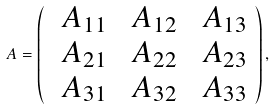<formula> <loc_0><loc_0><loc_500><loc_500>\ A = \left ( \begin{array} { c c c } \ A _ { 1 1 } & \ A _ { 1 2 } & \ A _ { 1 3 } \\ \ A _ { 2 1 } & \ A _ { 2 2 } & \ A _ { 2 3 } \\ \ A _ { 3 1 } & \ A _ { 3 2 } & \ A _ { 3 3 } \\ \end{array} \right ) ,</formula> 